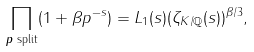Convert formula to latex. <formula><loc_0><loc_0><loc_500><loc_500>\prod _ { \text {$p$ split} } ( 1 + \beta p ^ { - s } ) = L _ { 1 } ( s ) ( \zeta _ { K / \mathbb { Q } } ( s ) ) ^ { \beta / 3 } ,</formula> 